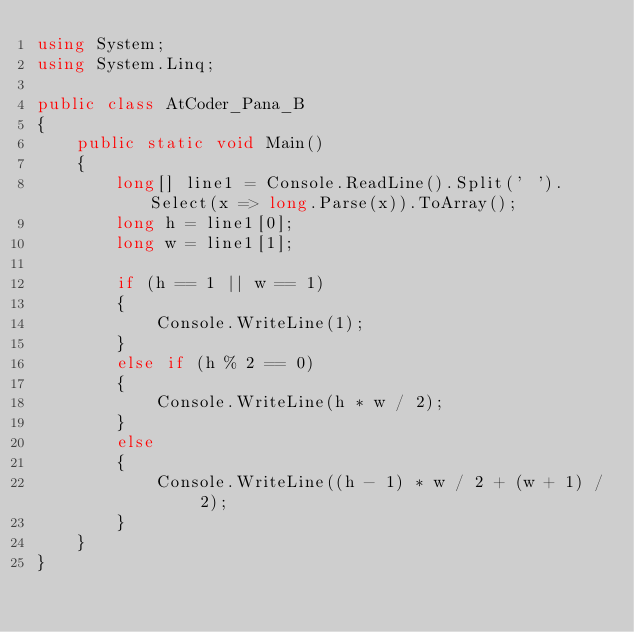<code> <loc_0><loc_0><loc_500><loc_500><_C#_>using System;
using System.Linq;

public class AtCoder_Pana_B
{
    public static void Main()
    {
        long[] line1 = Console.ReadLine().Split(' ').Select(x => long.Parse(x)).ToArray();
        long h = line1[0];
        long w = line1[1];

        if (h == 1 || w == 1)
        {
            Console.WriteLine(1);
        }
        else if (h % 2 == 0)
        {
            Console.WriteLine(h * w / 2);
        }
        else
        {
            Console.WriteLine((h - 1) * w / 2 + (w + 1) / 2);
        }
    }
}
</code> 